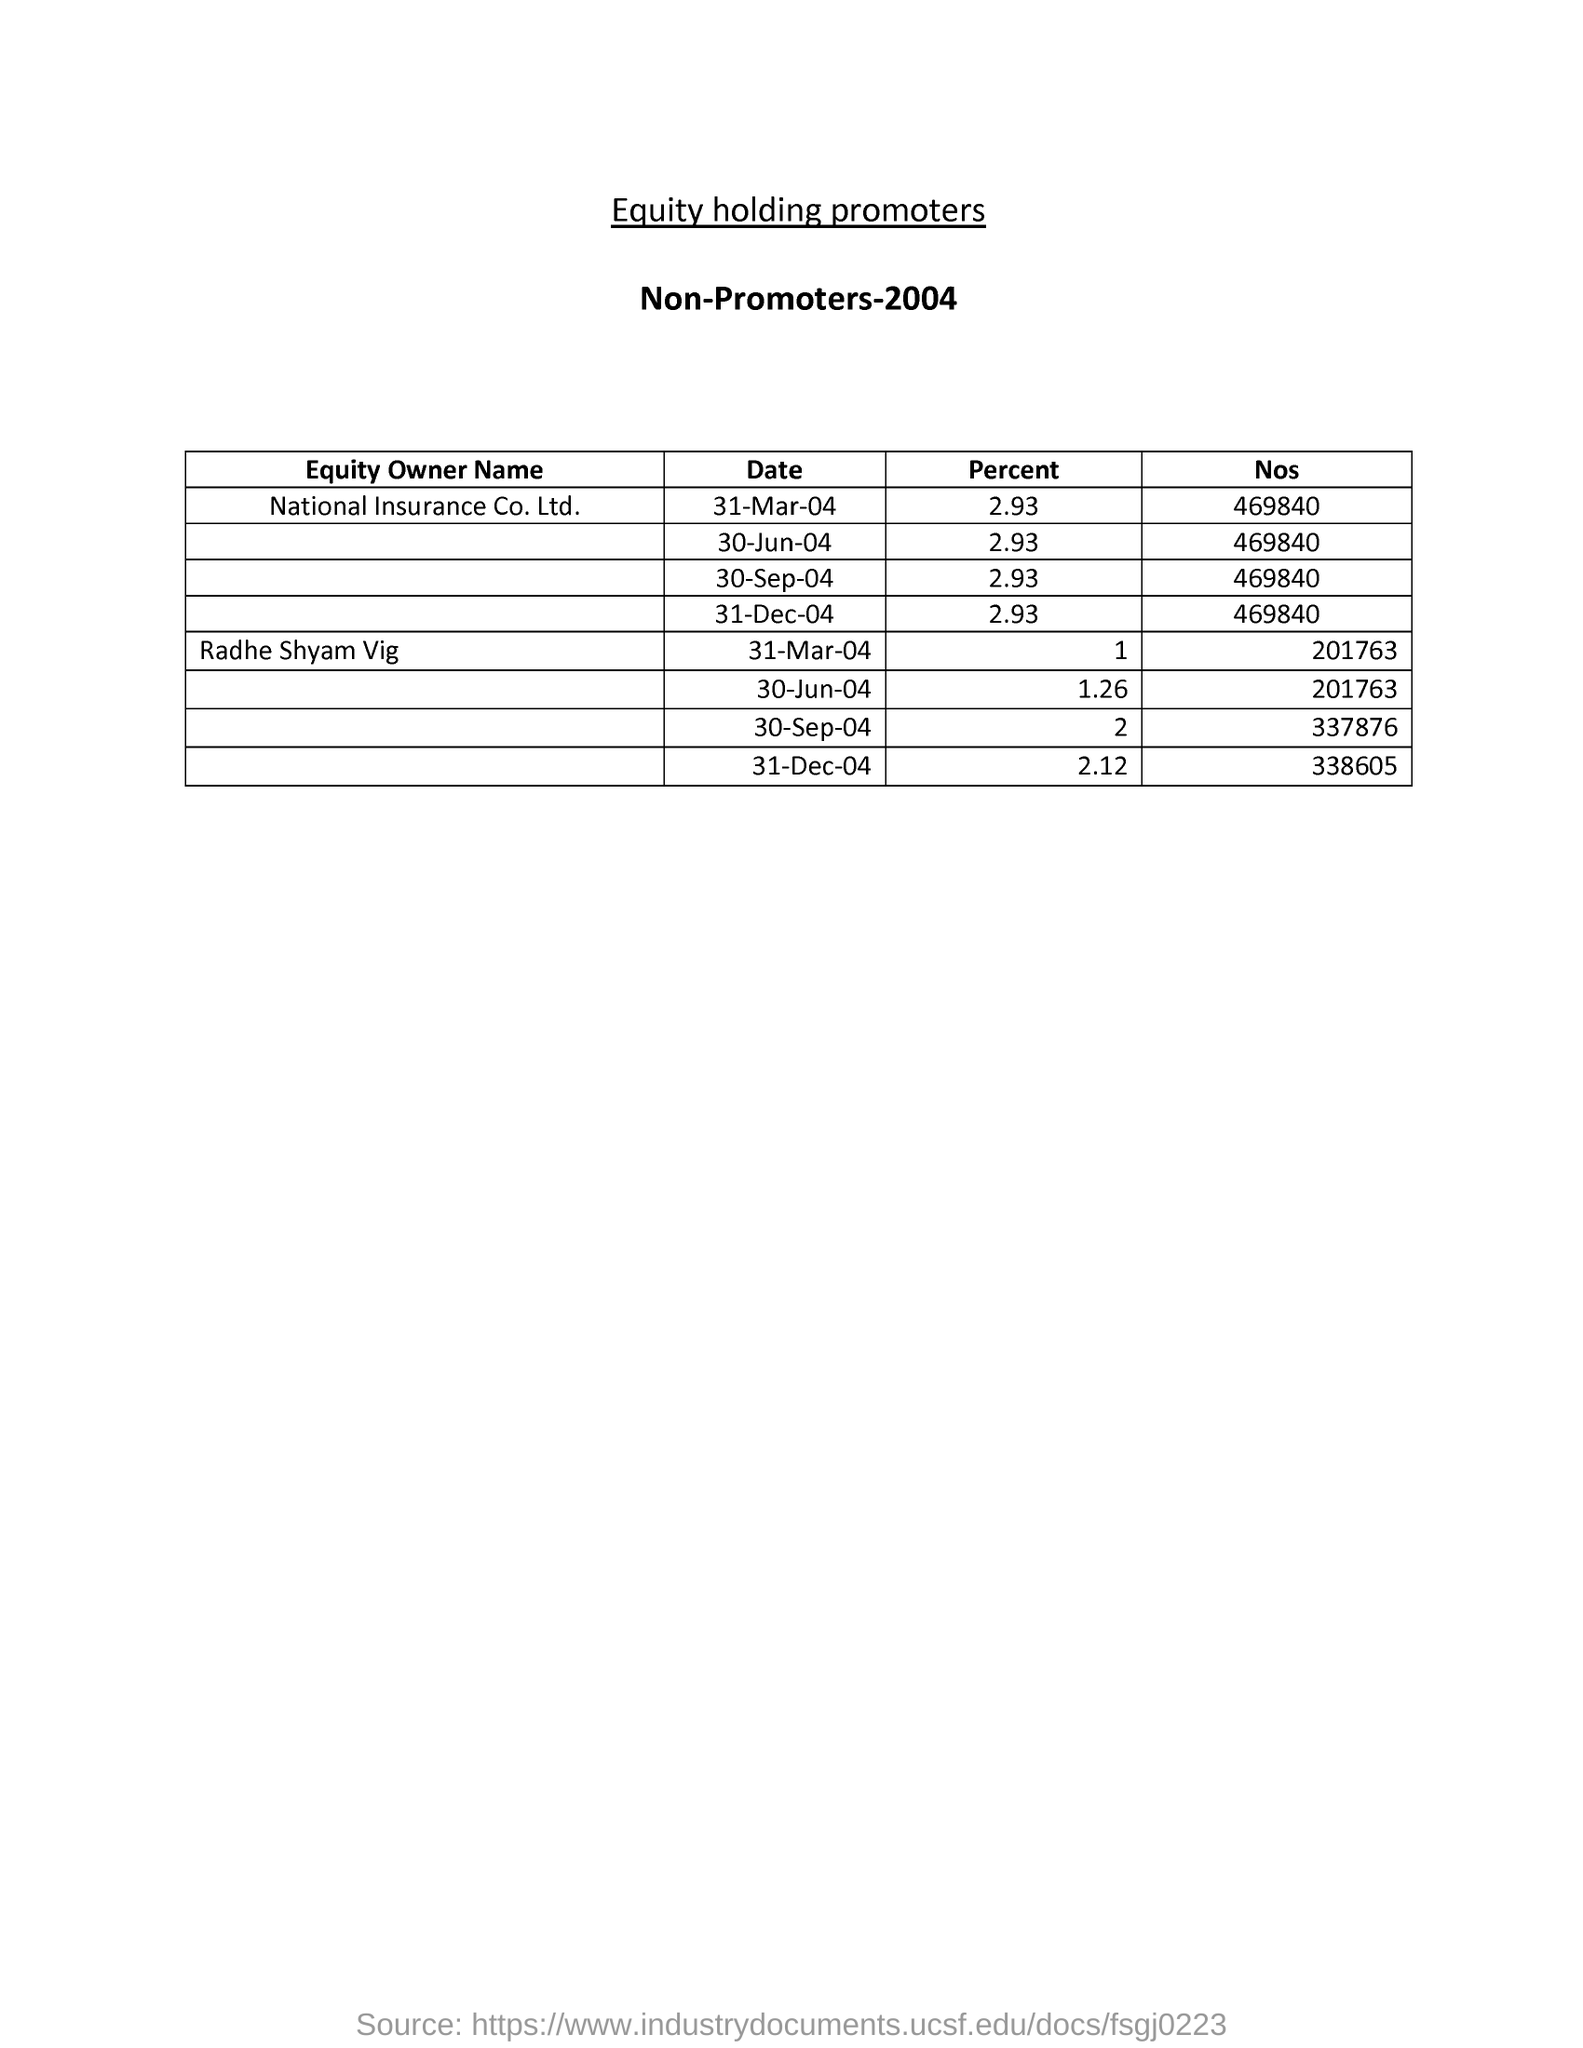What is the percentage corresponding to National Insurance Co. Ltd. on 31- Mar-04?
Your answer should be very brief. 2.93. 